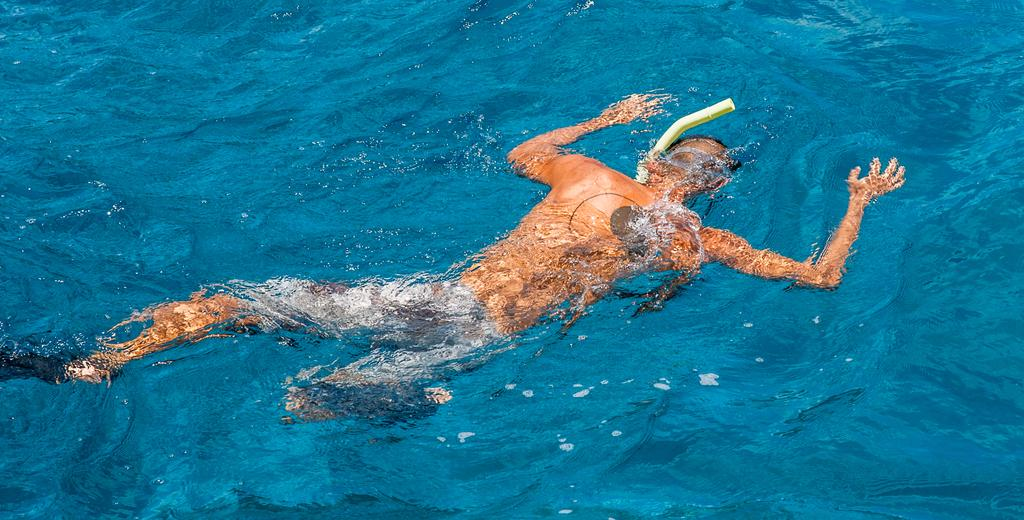What is the main subject of the image? There is a human in the water in the image. What type of snail can be seen running on the human's back in the image? There is no snail present in the image, and the human is not running. 